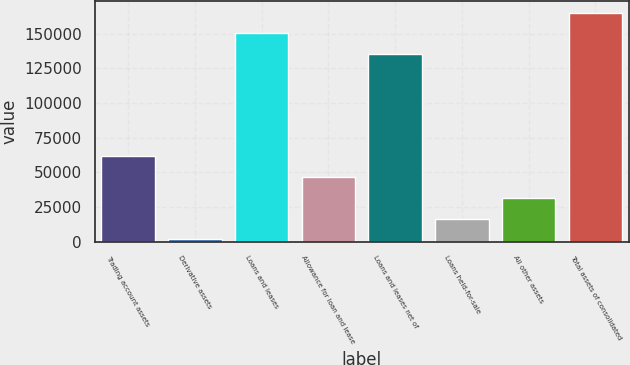Convert chart to OTSL. <chart><loc_0><loc_0><loc_500><loc_500><bar_chart><fcel>Trading account assets<fcel>Derivative assets<fcel>Loans and leases<fcel>Allowance for loan and lease<fcel>Loans and leases net of<fcel>Loans held-for-sale<fcel>All other assets<fcel>Total assets of consolidated<nl><fcel>61684.8<fcel>1634<fcel>150141<fcel>46672.1<fcel>135128<fcel>16646.7<fcel>31659.4<fcel>165153<nl></chart> 